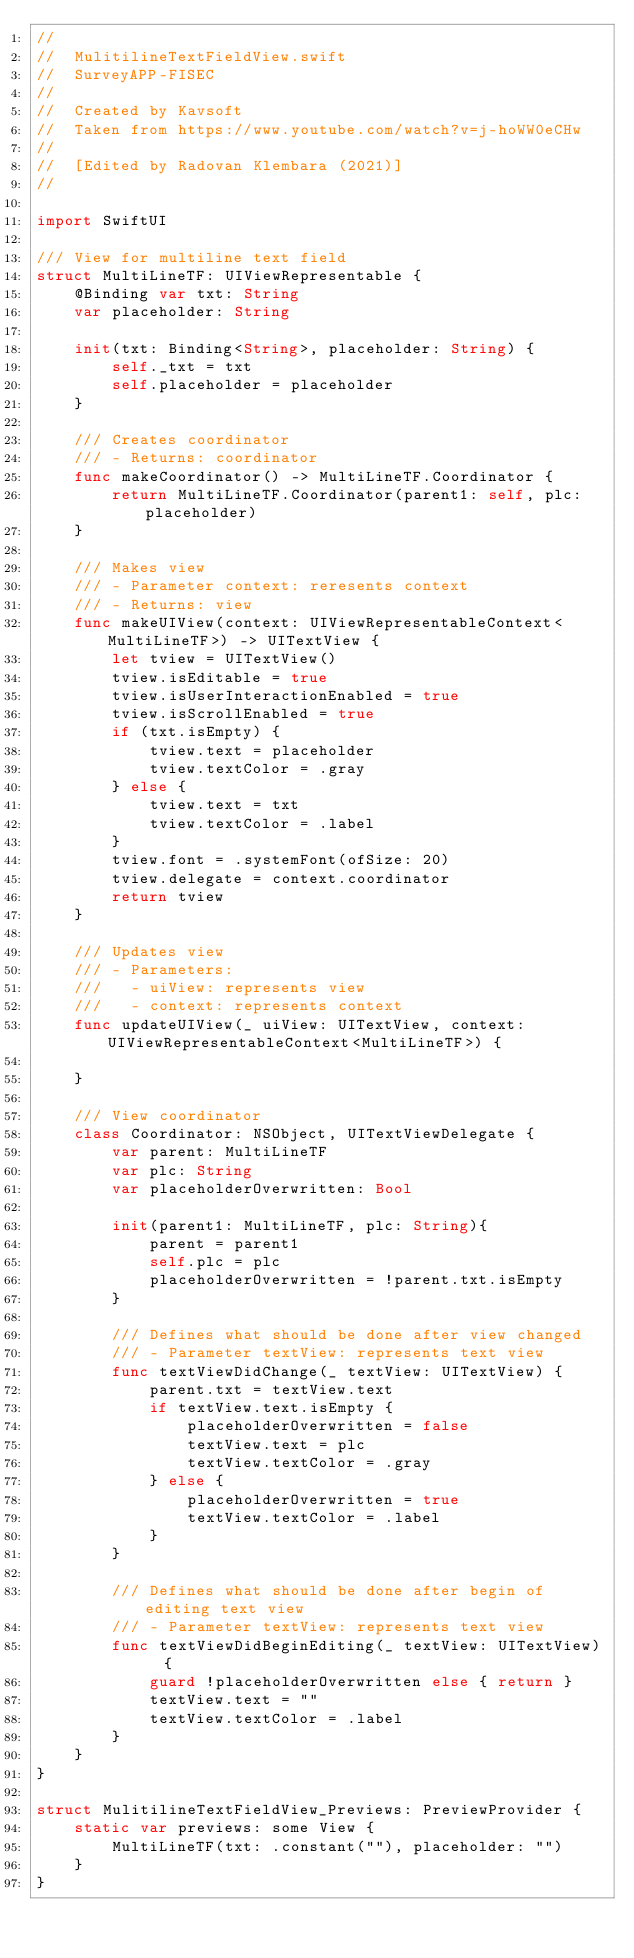<code> <loc_0><loc_0><loc_500><loc_500><_Swift_>//
//  MulitilineTextFieldView.swift
//  SurveyAPP-FISEC
//
//  Created by Kavsoft
//  Taken from https://www.youtube.com/watch?v=j-hoWW0eCHw
//
//  [Edited by Radovan Klembara (2021)]
//

import SwiftUI

/// View for multiline text field
struct MultiLineTF: UIViewRepresentable {
    @Binding var txt: String
    var placeholder: String
    
    init(txt: Binding<String>, placeholder: String) {
        self._txt = txt
        self.placeholder = placeholder
    }
    
    /// Creates coordinator
    /// - Returns: coordinator
    func makeCoordinator() -> MultiLineTF.Coordinator {
        return MultiLineTF.Coordinator(parent1: self, plc: placeholder)
    }
    
    /// Makes view
    /// - Parameter context: reresents context
    /// - Returns: view
    func makeUIView(context: UIViewRepresentableContext<MultiLineTF>) -> UITextView {
        let tview = UITextView()
        tview.isEditable = true
        tview.isUserInteractionEnabled = true
        tview.isScrollEnabled = true
        if (txt.isEmpty) {
            tview.text = placeholder
            tview.textColor = .gray
        } else {
            tview.text = txt
            tview.textColor = .label
        }
        tview.font = .systemFont(ofSize: 20)
        tview.delegate = context.coordinator
        return tview
    }
    
    /// Updates view
    /// - Parameters:
    ///   - uiView: represents view
    ///   - context: represents context
    func updateUIView(_ uiView: UITextView, context: UIViewRepresentableContext<MultiLineTF>) {
        
    }
    
    /// View coordinator
    class Coordinator: NSObject, UITextViewDelegate {
        var parent: MultiLineTF
        var plc: String
        var placeholderOverwritten: Bool
        
        init(parent1: MultiLineTF, plc: String){
            parent = parent1
            self.plc = plc
            placeholderOverwritten = !parent.txt.isEmpty
        }
        
        /// Defines what should be done after view changed
        /// - Parameter textView: represents text view
        func textViewDidChange(_ textView: UITextView) {
            parent.txt = textView.text
            if textView.text.isEmpty {
                placeholderOverwritten = false
                textView.text = plc
                textView.textColor = .gray
            } else {
                placeholderOverwritten = true
                textView.textColor = .label
            }
        }
        
        /// Defines what should be done after begin of editing text view
        /// - Parameter textView: represents text view
        func textViewDidBeginEditing(_ textView: UITextView)  {
            guard !placeholderOverwritten else { return }
            textView.text = ""
            textView.textColor = .label
        }
    }
}

struct MulitilineTextFieldView_Previews: PreviewProvider {
    static var previews: some View {
        MultiLineTF(txt: .constant(""), placeholder: "")
    }
}
</code> 